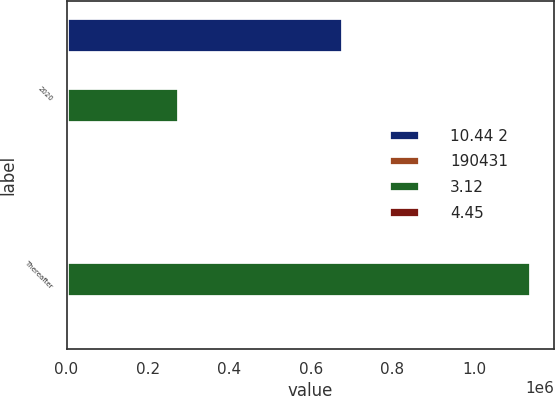Convert chart. <chart><loc_0><loc_0><loc_500><loc_500><stacked_bar_chart><ecel><fcel>2020<fcel>Thereafter<nl><fcel>10.44 2<fcel>678018<fcel>4.26<nl><fcel>190431<fcel>4.11<fcel>4.26<nl><fcel>3.12<fcel>275000<fcel>1.14e+06<nl><fcel>4.45<fcel>3.49<fcel>4.14<nl></chart> 